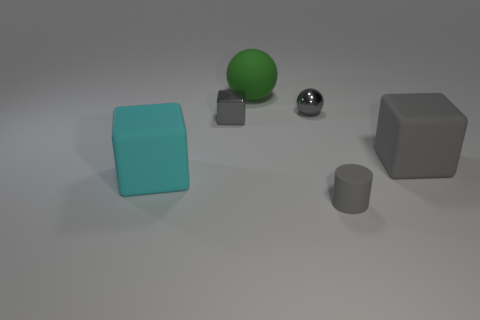What number of other objects are the same size as the cyan cube?
Your answer should be very brief. 2. Are there any other things that have the same shape as the small gray rubber object?
Make the answer very short. No. The other big matte object that is the same shape as the big cyan matte object is what color?
Provide a short and direct response. Gray. There is a tiny cylinder that is made of the same material as the cyan cube; what color is it?
Your answer should be very brief. Gray. Are there the same number of cyan rubber blocks that are in front of the tiny matte cylinder and cyan things?
Keep it short and to the point. No. There is a sphere in front of the green matte ball; is its size the same as the large rubber sphere?
Give a very brief answer. No. There is another rubber block that is the same size as the gray matte block; what color is it?
Make the answer very short. Cyan. Is there a small gray metallic object in front of the large rubber cube on the right side of the small shiny object that is to the right of the large green matte sphere?
Make the answer very short. No. There is a large thing right of the small cylinder; what is it made of?
Keep it short and to the point. Rubber. There is a large cyan object; is its shape the same as the large object that is right of the small cylinder?
Keep it short and to the point. Yes. 